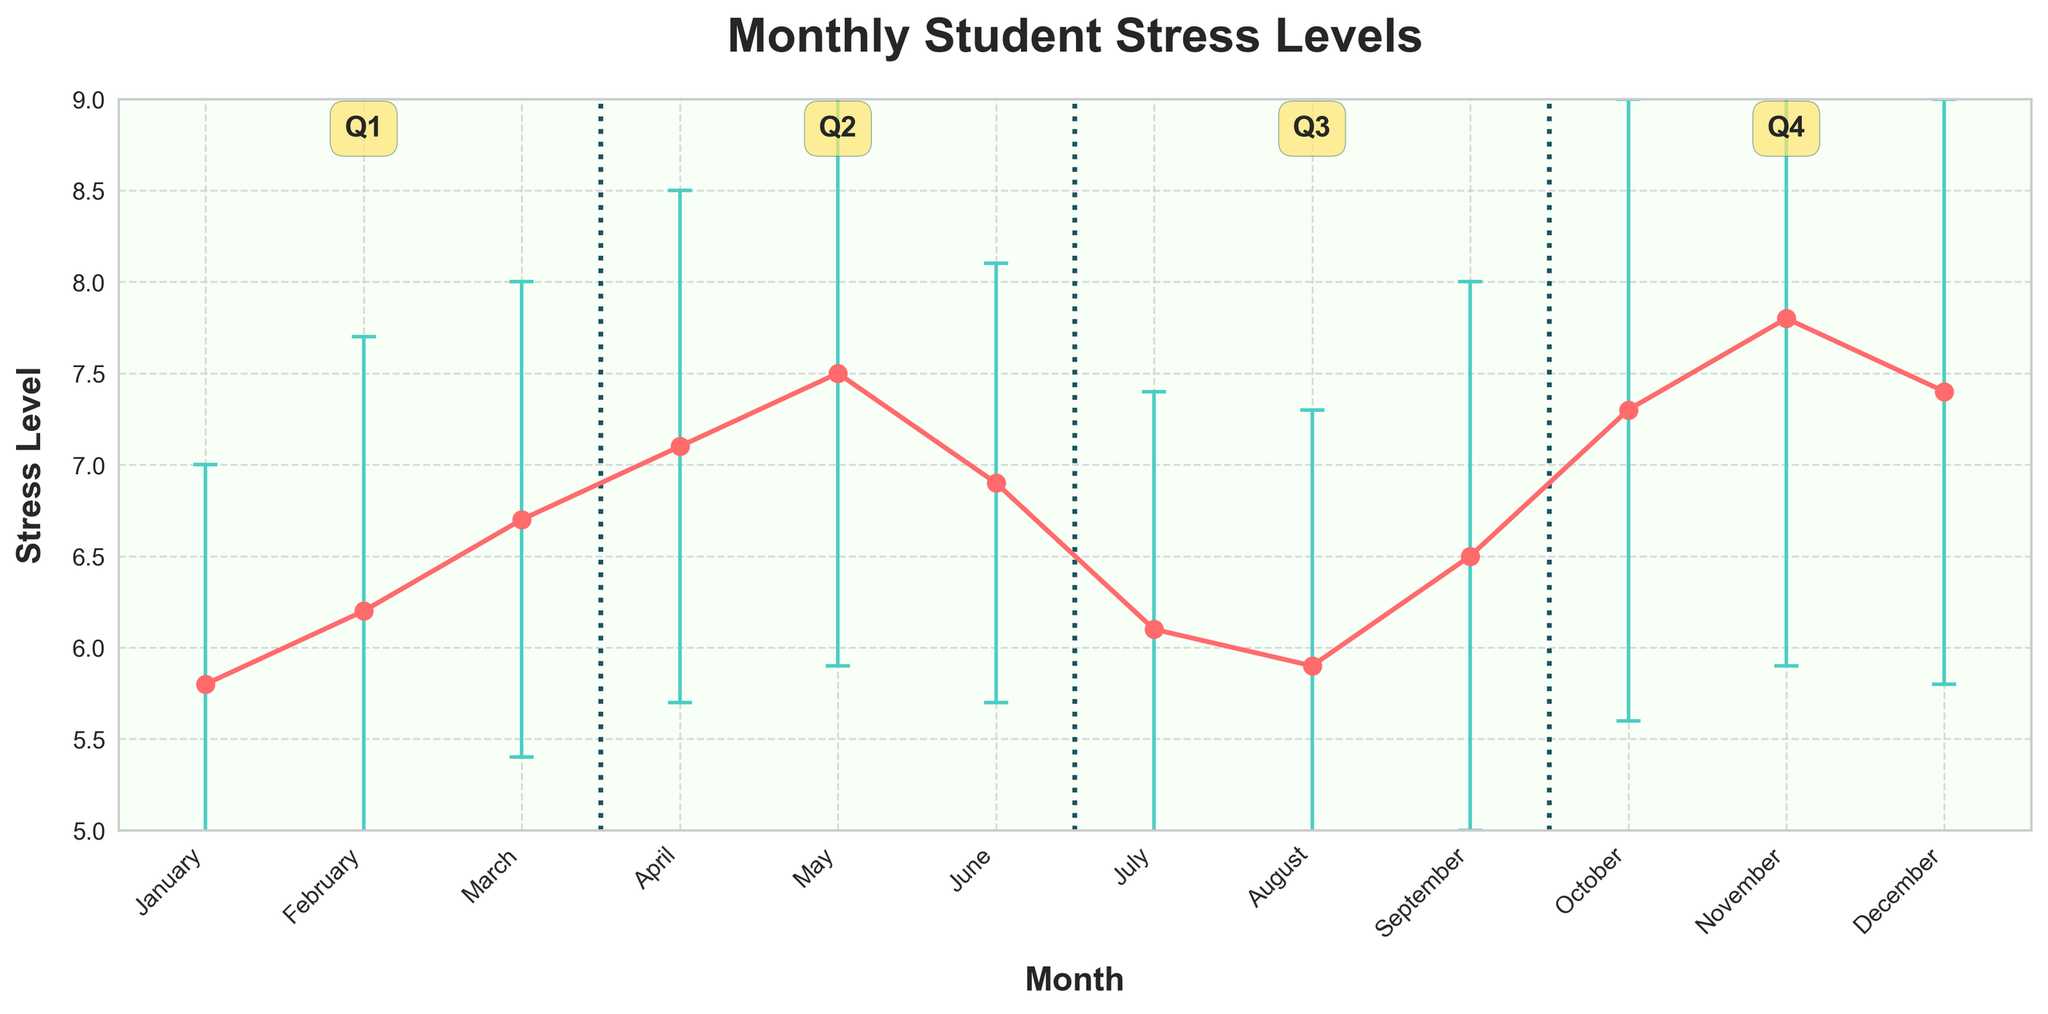What's the title of the plot? The title is written at the top of the plot.
Answer: Monthly Student Stress Levels How many data points are there for each month? Each month has one data point which represents the mean stress level for that month.
Answer: One Which month has the lowest mean stress level? By observing the plot, the month with the lowest mean stress level is identified by the lowest point on the y-axis.
Answer: January Which quarter has the highest average stress level? The average stress levels of each quarter can be visually compared by averaging the monthly values within each segment of the plot. The averages are: Q1 (5.8, 6.2, 6.7) = 6.23, Q2 (7.1, 7.5, 6.9) = 7.17, Q3 (6.1, 5.9, 6.5) = 6.17, Q4 (7.3, 7.8, 7.4) = 7.5.
Answer: Q4 What is the range of stress levels in November? The range can be calculated by adding and subtracting the standard deviation from the mean stress level of November (7.8 ± 1.9).
Answer: 5.9 to 9.7 Which month's stress level is closest to the overall plot median? By first identifying all monthly mean stress levels (5.8, 6.2, 6.7, 7.1, 7.5, 6.9, 6.1, 5.9, 6.5, 7.3, 7.8, 7.4) and then finding the median, which is between 6.7 and 6.9, the closest month to this value is June.
Answer: June How does the stress level in July compare to that in October? By visually inspecting the plot, the stress level in July is lower than that in October.
Answer: Lower During which quarter do we see the largest variation in stress levels? By comparing the standard deviations of each quarter (Q1: 1.2, 1.5, 1.3; Q2: 1.4, 1.6, 1.2; Q3: 1.3, 1.4, 1.5; Q4: 1.7, 1.9, 1.6), Q4 has the highest standard deviations, indicating the largest variation.
Answer: Q4 What's the trend in stress levels from Q2 to Q3? Observing the line from April to September, the trend declines from April to August and then increases slightly in September.
Answer: Decreasing then Increasing 